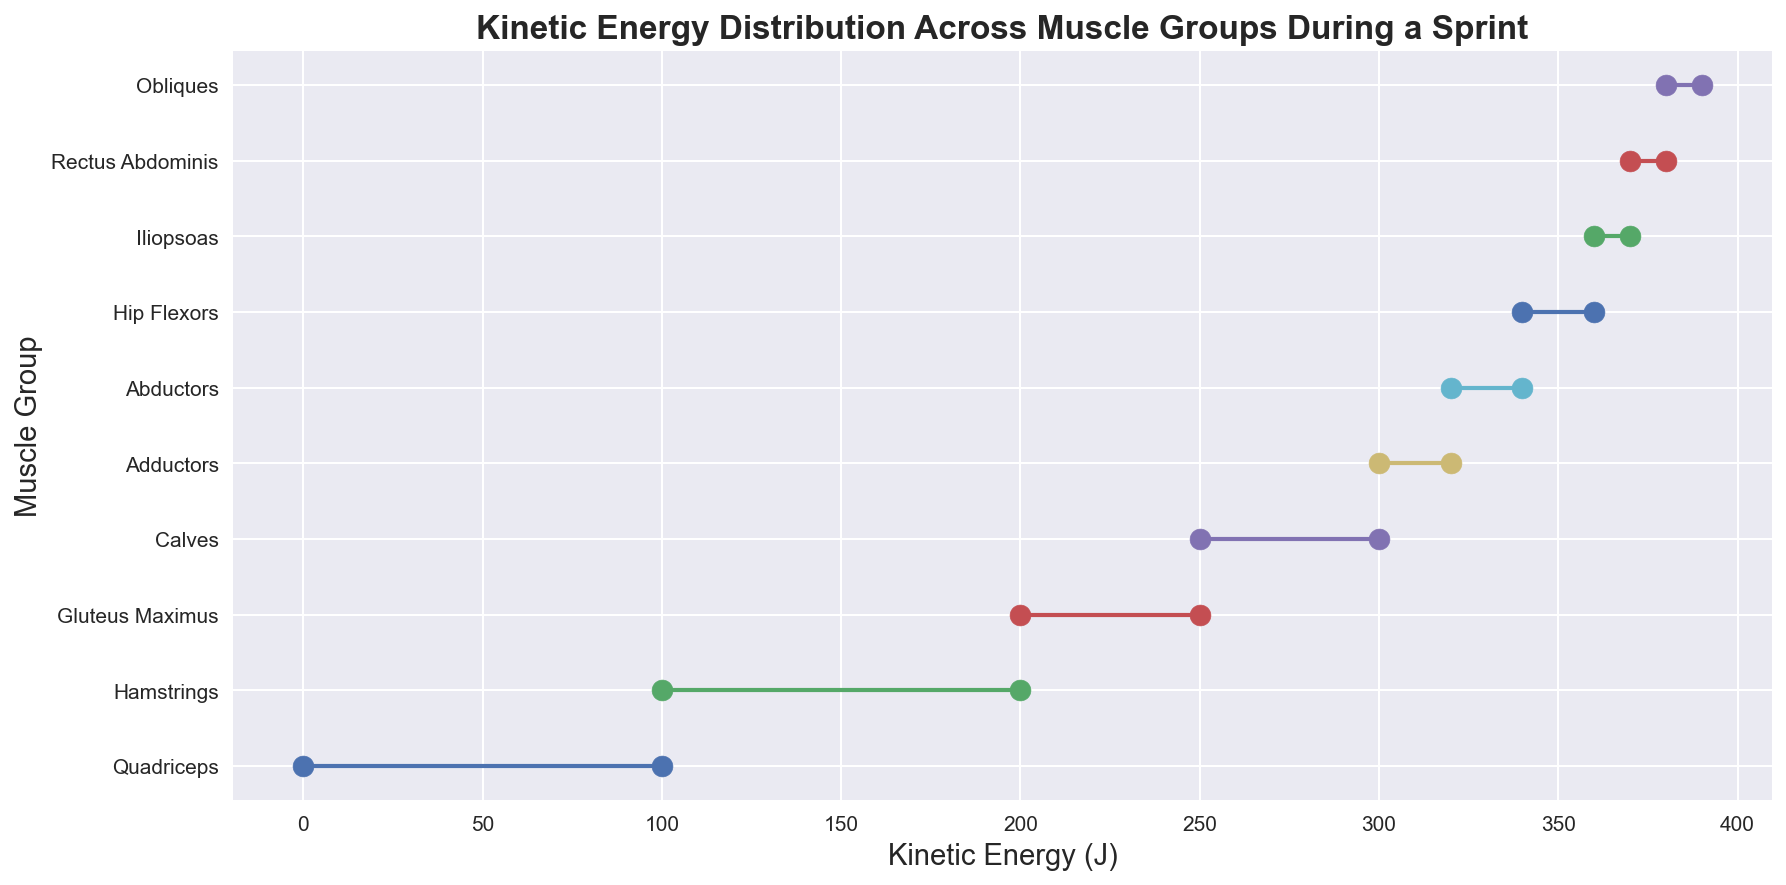Which muscle group has the highest end kinetic energy? To find the muscle group with the highest end kinetic energy, look for the muscle group with the highest value on the kinetic energy x-axis at the end of its segment. "Obliques" has the highest end kinetic energy value of 390 J.
Answer: Obliques Which muscle group has the smallest change in kinetic energy? The change in kinetic energy is the difference between the end kinetic energy and start kinetic energy for each muscle group. Look for the smallest difference. The difference for Iliopsoas is 370 - 360 = 10 J, which is the smallest.
Answer: Iliopsoas Which has a higher increase in kinetic energy: Gluteus Maximus or Calves? Calculate the increase for each muscle group by subtracting the start kinetic energy from the end kinetic energy. Gluteus Maximus: 250 - 200 = 50 J. Calves: 300 - 250 = 50 J. Both have the same increase in kinetic energy.
Answer: Both are equal What is the total kinetic energy change for the Quadriceps, Hamstrings, and Gluteus Maximus combined? Compute the individual changes and sum them up: Quadriceps: 100 - 0 = 100 J, Hamstrings: 200 - 100 = 100 J, Gluteus Maximus: 250 - 200 = 50 J. Total change: 100 + 100 + 50 = 250 J.
Answer: 250 J What is the mean end kinetic energy for the first five muscle groups? Add the end kinetic energy of the first five muscle groups and divide by 5. (100 + 200 + 250 + 300 + 320) / 5 = 1170 / 5 = 234 J.
Answer: 234 J Which muscle group has the same visual color as the quadriceps? To find the muscle group with the same color, visually match the color of the "Quadriceps" segment. Since each segment has a unique color, none of the muscle groups share the same color as the Quadriceps.
Answer: None Are the end kinetic energy values for the Iliopsoas and Rectus Abdominis within 10 J of each other? Compare the end kinetic energy values: Iliopsoas: 370 J, Rectus Abdominis: 380 J. The difference is 380 - 370 = 10 J. Yes, they are exactly 10 J apart.
Answer: Yes, within 10 J Which muscle group shows a kinetic energy range that spans exactly 20 J? Calculate the kinetic energy range (end KE - start KE) for each group and check if it equals 20 J. Both Adductors: (320 - 300 = 20 J) and Abductors (340 - 320 = 20 J) span 20 J.
Answer: Adductors and Abductors Which muscle group has an end kinetic energy value closest to the median end kinetic energy of all groups? First, find the median end kinetic energy. Ordered end KE values: 100, 200, 250, 300, 320, 340, 360, 370, 380, 390. The median is (320 + 340) / 2 = 330 J. The closest is "Calves" with 300 J.
Answer: Calves 